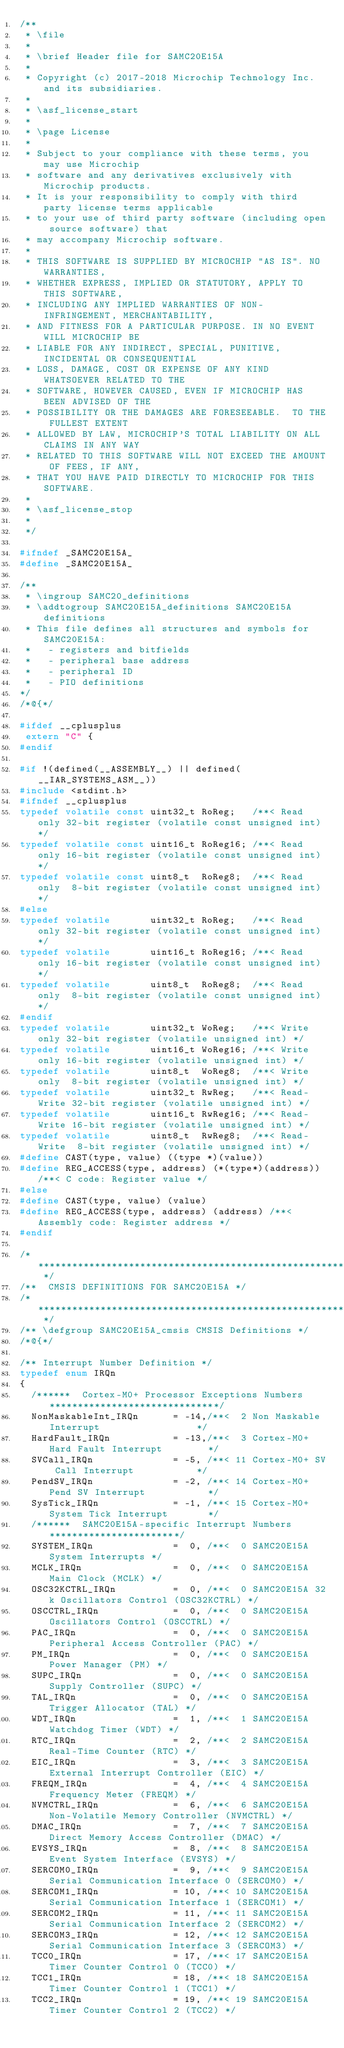Convert code to text. <code><loc_0><loc_0><loc_500><loc_500><_C_>/**
 * \file
 *
 * \brief Header file for SAMC20E15A
 *
 * Copyright (c) 2017-2018 Microchip Technology Inc. and its subsidiaries.
 *
 * \asf_license_start
 *
 * \page License
 *
 * Subject to your compliance with these terms, you may use Microchip
 * software and any derivatives exclusively with Microchip products.
 * It is your responsibility to comply with third party license terms applicable
 * to your use of third party software (including open source software) that
 * may accompany Microchip software.
 *
 * THIS SOFTWARE IS SUPPLIED BY MICROCHIP "AS IS". NO WARRANTIES,
 * WHETHER EXPRESS, IMPLIED OR STATUTORY, APPLY TO THIS SOFTWARE,
 * INCLUDING ANY IMPLIED WARRANTIES OF NON-INFRINGEMENT, MERCHANTABILITY,
 * AND FITNESS FOR A PARTICULAR PURPOSE. IN NO EVENT WILL MICROCHIP BE
 * LIABLE FOR ANY INDIRECT, SPECIAL, PUNITIVE, INCIDENTAL OR CONSEQUENTIAL
 * LOSS, DAMAGE, COST OR EXPENSE OF ANY KIND WHATSOEVER RELATED TO THE
 * SOFTWARE, HOWEVER CAUSED, EVEN IF MICROCHIP HAS BEEN ADVISED OF THE
 * POSSIBILITY OR THE DAMAGES ARE FORESEEABLE.  TO THE FULLEST EXTENT
 * ALLOWED BY LAW, MICROCHIP'S TOTAL LIABILITY ON ALL CLAIMS IN ANY WAY
 * RELATED TO THIS SOFTWARE WILL NOT EXCEED THE AMOUNT OF FEES, IF ANY,
 * THAT YOU HAVE PAID DIRECTLY TO MICROCHIP FOR THIS SOFTWARE.
 *
 * \asf_license_stop
 *
 */

#ifndef _SAMC20E15A_
#define _SAMC20E15A_

/**
 * \ingroup SAMC20_definitions
 * \addtogroup SAMC20E15A_definitions SAMC20E15A definitions
 * This file defines all structures and symbols for SAMC20E15A:
 *   - registers and bitfields
 *   - peripheral base address
 *   - peripheral ID
 *   - PIO definitions
*/
/*@{*/

#ifdef __cplusplus
 extern "C" {
#endif

#if !(defined(__ASSEMBLY__) || defined(__IAR_SYSTEMS_ASM__))
#include <stdint.h>
#ifndef __cplusplus
typedef volatile const uint32_t RoReg;   /**< Read only 32-bit register (volatile const unsigned int) */
typedef volatile const uint16_t RoReg16; /**< Read only 16-bit register (volatile const unsigned int) */
typedef volatile const uint8_t  RoReg8;  /**< Read only  8-bit register (volatile const unsigned int) */
#else
typedef volatile       uint32_t RoReg;   /**< Read only 32-bit register (volatile const unsigned int) */
typedef volatile       uint16_t RoReg16; /**< Read only 16-bit register (volatile const unsigned int) */
typedef volatile       uint8_t  RoReg8;  /**< Read only  8-bit register (volatile const unsigned int) */
#endif
typedef volatile       uint32_t WoReg;   /**< Write only 32-bit register (volatile unsigned int) */
typedef volatile       uint16_t WoReg16; /**< Write only 16-bit register (volatile unsigned int) */
typedef volatile       uint8_t  WoReg8;  /**< Write only  8-bit register (volatile unsigned int) */
typedef volatile       uint32_t RwReg;   /**< Read-Write 32-bit register (volatile unsigned int) */
typedef volatile       uint16_t RwReg16; /**< Read-Write 16-bit register (volatile unsigned int) */
typedef volatile       uint8_t  RwReg8;  /**< Read-Write  8-bit register (volatile unsigned int) */
#define CAST(type, value) ((type *)(value))
#define REG_ACCESS(type, address) (*(type*)(address)) /**< C code: Register value */
#else
#define CAST(type, value) (value)
#define REG_ACCESS(type, address) (address) /**< Assembly code: Register address */
#endif

/* ************************************************************************** */
/**  CMSIS DEFINITIONS FOR SAMC20E15A */
/* ************************************************************************** */
/** \defgroup SAMC20E15A_cmsis CMSIS Definitions */
/*@{*/

/** Interrupt Number Definition */
typedef enum IRQn
{
  /******  Cortex-M0+ Processor Exceptions Numbers ******************************/
  NonMaskableInt_IRQn      = -14,/**<  2 Non Maskable Interrupt                 */
  HardFault_IRQn           = -13,/**<  3 Cortex-M0+ Hard Fault Interrupt        */
  SVCall_IRQn              = -5, /**< 11 Cortex-M0+ SV Call Interrupt           */
  PendSV_IRQn              = -2, /**< 14 Cortex-M0+ Pend SV Interrupt           */
  SysTick_IRQn             = -1, /**< 15 Cortex-M0+ System Tick Interrupt       */
  /******  SAMC20E15A-specific Interrupt Numbers ***********************/
  SYSTEM_IRQn              =  0, /**<  0 SAMC20E15A System Interrupts */
  MCLK_IRQn                =  0, /**<  0 SAMC20E15A Main Clock (MCLK) */
  OSC32KCTRL_IRQn          =  0, /**<  0 SAMC20E15A 32k Oscillators Control (OSC32KCTRL) */
  OSCCTRL_IRQn             =  0, /**<  0 SAMC20E15A Oscillators Control (OSCCTRL) */
  PAC_IRQn                 =  0, /**<  0 SAMC20E15A Peripheral Access Controller (PAC) */
  PM_IRQn                  =  0, /**<  0 SAMC20E15A Power Manager (PM) */
  SUPC_IRQn                =  0, /**<  0 SAMC20E15A Supply Controller (SUPC) */
  TAL_IRQn                 =  0, /**<  0 SAMC20E15A Trigger Allocator (TAL) */
  WDT_IRQn                 =  1, /**<  1 SAMC20E15A Watchdog Timer (WDT) */
  RTC_IRQn                 =  2, /**<  2 SAMC20E15A Real-Time Counter (RTC) */
  EIC_IRQn                 =  3, /**<  3 SAMC20E15A External Interrupt Controller (EIC) */
  FREQM_IRQn               =  4, /**<  4 SAMC20E15A Frequency Meter (FREQM) */
  NVMCTRL_IRQn             =  6, /**<  6 SAMC20E15A Non-Volatile Memory Controller (NVMCTRL) */
  DMAC_IRQn                =  7, /**<  7 SAMC20E15A Direct Memory Access Controller (DMAC) */
  EVSYS_IRQn               =  8, /**<  8 SAMC20E15A Event System Interface (EVSYS) */
  SERCOM0_IRQn             =  9, /**<  9 SAMC20E15A Serial Communication Interface 0 (SERCOM0) */
  SERCOM1_IRQn             = 10, /**< 10 SAMC20E15A Serial Communication Interface 1 (SERCOM1) */
  SERCOM2_IRQn             = 11, /**< 11 SAMC20E15A Serial Communication Interface 2 (SERCOM2) */
  SERCOM3_IRQn             = 12, /**< 12 SAMC20E15A Serial Communication Interface 3 (SERCOM3) */
  TCC0_IRQn                = 17, /**< 17 SAMC20E15A Timer Counter Control 0 (TCC0) */
  TCC1_IRQn                = 18, /**< 18 SAMC20E15A Timer Counter Control 1 (TCC1) */
  TCC2_IRQn                = 19, /**< 19 SAMC20E15A Timer Counter Control 2 (TCC2) */</code> 